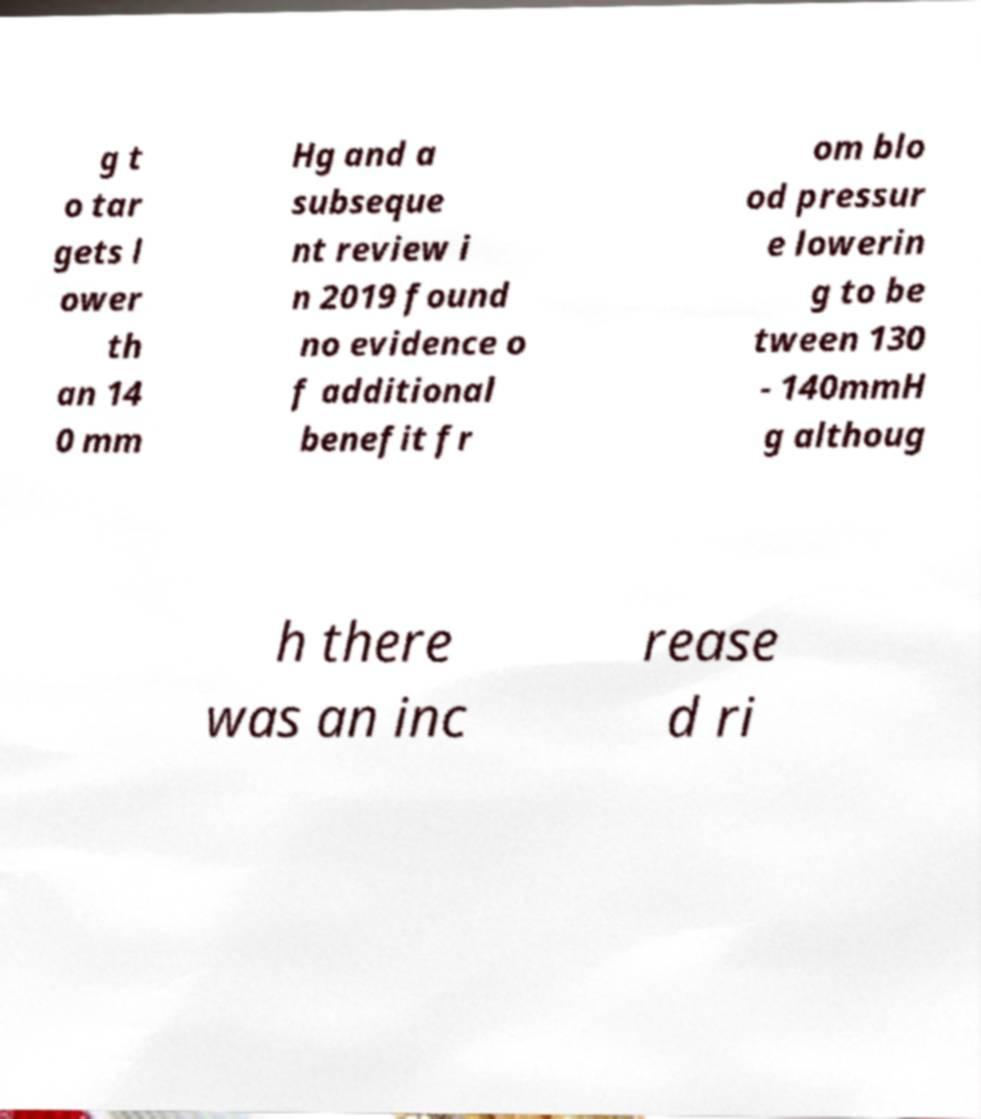Can you accurately transcribe the text from the provided image for me? g t o tar gets l ower th an 14 0 mm Hg and a subseque nt review i n 2019 found no evidence o f additional benefit fr om blo od pressur e lowerin g to be tween 130 - 140mmH g althoug h there was an inc rease d ri 